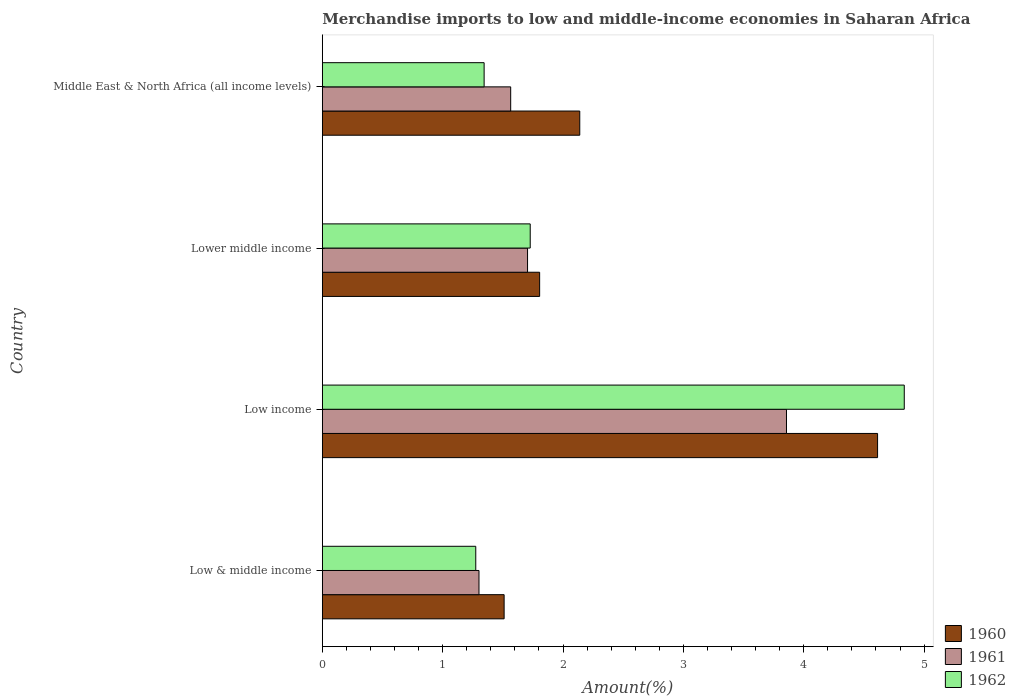How many different coloured bars are there?
Give a very brief answer. 3. Are the number of bars on each tick of the Y-axis equal?
Provide a succinct answer. Yes. How many bars are there on the 1st tick from the bottom?
Ensure brevity in your answer.  3. What is the percentage of amount earned from merchandise imports in 1960 in Low & middle income?
Your response must be concise. 1.51. Across all countries, what is the maximum percentage of amount earned from merchandise imports in 1961?
Provide a succinct answer. 3.86. Across all countries, what is the minimum percentage of amount earned from merchandise imports in 1962?
Offer a very short reply. 1.27. In which country was the percentage of amount earned from merchandise imports in 1962 minimum?
Your answer should be very brief. Low & middle income. What is the total percentage of amount earned from merchandise imports in 1962 in the graph?
Offer a terse response. 9.18. What is the difference between the percentage of amount earned from merchandise imports in 1961 in Low income and that in Middle East & North Africa (all income levels)?
Offer a terse response. 2.29. What is the difference between the percentage of amount earned from merchandise imports in 1961 in Low & middle income and the percentage of amount earned from merchandise imports in 1960 in Middle East & North Africa (all income levels)?
Provide a succinct answer. -0.84. What is the average percentage of amount earned from merchandise imports in 1961 per country?
Keep it short and to the point. 2.11. What is the difference between the percentage of amount earned from merchandise imports in 1962 and percentage of amount earned from merchandise imports in 1961 in Lower middle income?
Make the answer very short. 0.02. What is the ratio of the percentage of amount earned from merchandise imports in 1962 in Low & middle income to that in Lower middle income?
Your answer should be very brief. 0.74. Is the percentage of amount earned from merchandise imports in 1961 in Low & middle income less than that in Lower middle income?
Offer a very short reply. Yes. Is the difference between the percentage of amount earned from merchandise imports in 1962 in Low income and Middle East & North Africa (all income levels) greater than the difference between the percentage of amount earned from merchandise imports in 1961 in Low income and Middle East & North Africa (all income levels)?
Offer a very short reply. Yes. What is the difference between the highest and the second highest percentage of amount earned from merchandise imports in 1961?
Your answer should be compact. 2.15. What is the difference between the highest and the lowest percentage of amount earned from merchandise imports in 1962?
Keep it short and to the point. 3.56. What does the 2nd bar from the top in Lower middle income represents?
Provide a short and direct response. 1961. How many bars are there?
Your response must be concise. 12. Are the values on the major ticks of X-axis written in scientific E-notation?
Provide a short and direct response. No. Where does the legend appear in the graph?
Give a very brief answer. Bottom right. How many legend labels are there?
Give a very brief answer. 3. How are the legend labels stacked?
Keep it short and to the point. Vertical. What is the title of the graph?
Provide a succinct answer. Merchandise imports to low and middle-income economies in Saharan Africa. Does "1988" appear as one of the legend labels in the graph?
Offer a terse response. No. What is the label or title of the X-axis?
Provide a succinct answer. Amount(%). What is the label or title of the Y-axis?
Provide a succinct answer. Country. What is the Amount(%) in 1960 in Low & middle income?
Your answer should be very brief. 1.51. What is the Amount(%) of 1961 in Low & middle income?
Offer a very short reply. 1.3. What is the Amount(%) in 1962 in Low & middle income?
Give a very brief answer. 1.27. What is the Amount(%) of 1960 in Low income?
Keep it short and to the point. 4.61. What is the Amount(%) in 1961 in Low income?
Your answer should be very brief. 3.86. What is the Amount(%) in 1962 in Low income?
Offer a very short reply. 4.84. What is the Amount(%) of 1960 in Lower middle income?
Provide a short and direct response. 1.81. What is the Amount(%) of 1961 in Lower middle income?
Offer a terse response. 1.71. What is the Amount(%) in 1962 in Lower middle income?
Offer a very short reply. 1.73. What is the Amount(%) of 1960 in Middle East & North Africa (all income levels)?
Provide a succinct answer. 2.14. What is the Amount(%) of 1961 in Middle East & North Africa (all income levels)?
Give a very brief answer. 1.57. What is the Amount(%) in 1962 in Middle East & North Africa (all income levels)?
Provide a succinct answer. 1.34. Across all countries, what is the maximum Amount(%) in 1960?
Provide a short and direct response. 4.61. Across all countries, what is the maximum Amount(%) in 1961?
Your response must be concise. 3.86. Across all countries, what is the maximum Amount(%) of 1962?
Give a very brief answer. 4.84. Across all countries, what is the minimum Amount(%) in 1960?
Your answer should be compact. 1.51. Across all countries, what is the minimum Amount(%) of 1961?
Keep it short and to the point. 1.3. Across all countries, what is the minimum Amount(%) in 1962?
Offer a very short reply. 1.27. What is the total Amount(%) in 1960 in the graph?
Provide a short and direct response. 10.07. What is the total Amount(%) in 1961 in the graph?
Ensure brevity in your answer.  8.43. What is the total Amount(%) in 1962 in the graph?
Make the answer very short. 9.18. What is the difference between the Amount(%) of 1960 in Low & middle income and that in Low income?
Give a very brief answer. -3.1. What is the difference between the Amount(%) of 1961 in Low & middle income and that in Low income?
Ensure brevity in your answer.  -2.56. What is the difference between the Amount(%) in 1962 in Low & middle income and that in Low income?
Your answer should be compact. -3.56. What is the difference between the Amount(%) of 1960 in Low & middle income and that in Lower middle income?
Offer a very short reply. -0.29. What is the difference between the Amount(%) of 1961 in Low & middle income and that in Lower middle income?
Your answer should be compact. -0.4. What is the difference between the Amount(%) of 1962 in Low & middle income and that in Lower middle income?
Your response must be concise. -0.45. What is the difference between the Amount(%) in 1960 in Low & middle income and that in Middle East & North Africa (all income levels)?
Your answer should be very brief. -0.63. What is the difference between the Amount(%) of 1961 in Low & middle income and that in Middle East & North Africa (all income levels)?
Offer a terse response. -0.26. What is the difference between the Amount(%) in 1962 in Low & middle income and that in Middle East & North Africa (all income levels)?
Your answer should be compact. -0.07. What is the difference between the Amount(%) of 1960 in Low income and that in Lower middle income?
Make the answer very short. 2.81. What is the difference between the Amount(%) of 1961 in Low income and that in Lower middle income?
Provide a succinct answer. 2.15. What is the difference between the Amount(%) of 1962 in Low income and that in Lower middle income?
Your answer should be compact. 3.11. What is the difference between the Amount(%) of 1960 in Low income and that in Middle East & North Africa (all income levels)?
Make the answer very short. 2.47. What is the difference between the Amount(%) of 1961 in Low income and that in Middle East & North Africa (all income levels)?
Provide a short and direct response. 2.29. What is the difference between the Amount(%) of 1962 in Low income and that in Middle East & North Africa (all income levels)?
Your response must be concise. 3.49. What is the difference between the Amount(%) in 1960 in Lower middle income and that in Middle East & North Africa (all income levels)?
Offer a very short reply. -0.33. What is the difference between the Amount(%) of 1961 in Lower middle income and that in Middle East & North Africa (all income levels)?
Provide a short and direct response. 0.14. What is the difference between the Amount(%) in 1962 in Lower middle income and that in Middle East & North Africa (all income levels)?
Make the answer very short. 0.38. What is the difference between the Amount(%) in 1960 in Low & middle income and the Amount(%) in 1961 in Low income?
Offer a very short reply. -2.35. What is the difference between the Amount(%) of 1960 in Low & middle income and the Amount(%) of 1962 in Low income?
Make the answer very short. -3.32. What is the difference between the Amount(%) in 1961 in Low & middle income and the Amount(%) in 1962 in Low income?
Offer a terse response. -3.53. What is the difference between the Amount(%) in 1960 in Low & middle income and the Amount(%) in 1961 in Lower middle income?
Give a very brief answer. -0.19. What is the difference between the Amount(%) of 1960 in Low & middle income and the Amount(%) of 1962 in Lower middle income?
Give a very brief answer. -0.22. What is the difference between the Amount(%) of 1961 in Low & middle income and the Amount(%) of 1962 in Lower middle income?
Your answer should be compact. -0.43. What is the difference between the Amount(%) in 1960 in Low & middle income and the Amount(%) in 1961 in Middle East & North Africa (all income levels)?
Offer a very short reply. -0.05. What is the difference between the Amount(%) of 1960 in Low & middle income and the Amount(%) of 1962 in Middle East & North Africa (all income levels)?
Your answer should be compact. 0.17. What is the difference between the Amount(%) in 1961 in Low & middle income and the Amount(%) in 1962 in Middle East & North Africa (all income levels)?
Provide a succinct answer. -0.04. What is the difference between the Amount(%) in 1960 in Low income and the Amount(%) in 1961 in Lower middle income?
Provide a short and direct response. 2.91. What is the difference between the Amount(%) in 1960 in Low income and the Amount(%) in 1962 in Lower middle income?
Offer a very short reply. 2.89. What is the difference between the Amount(%) in 1961 in Low income and the Amount(%) in 1962 in Lower middle income?
Ensure brevity in your answer.  2.13. What is the difference between the Amount(%) in 1960 in Low income and the Amount(%) in 1961 in Middle East & North Africa (all income levels)?
Offer a terse response. 3.05. What is the difference between the Amount(%) of 1960 in Low income and the Amount(%) of 1962 in Middle East & North Africa (all income levels)?
Your response must be concise. 3.27. What is the difference between the Amount(%) of 1961 in Low income and the Amount(%) of 1962 in Middle East & North Africa (all income levels)?
Keep it short and to the point. 2.51. What is the difference between the Amount(%) of 1960 in Lower middle income and the Amount(%) of 1961 in Middle East & North Africa (all income levels)?
Provide a succinct answer. 0.24. What is the difference between the Amount(%) in 1960 in Lower middle income and the Amount(%) in 1962 in Middle East & North Africa (all income levels)?
Your response must be concise. 0.46. What is the difference between the Amount(%) in 1961 in Lower middle income and the Amount(%) in 1962 in Middle East & North Africa (all income levels)?
Keep it short and to the point. 0.36. What is the average Amount(%) of 1960 per country?
Your answer should be very brief. 2.52. What is the average Amount(%) in 1961 per country?
Provide a succinct answer. 2.11. What is the average Amount(%) in 1962 per country?
Your response must be concise. 2.3. What is the difference between the Amount(%) of 1960 and Amount(%) of 1961 in Low & middle income?
Make the answer very short. 0.21. What is the difference between the Amount(%) of 1960 and Amount(%) of 1962 in Low & middle income?
Your answer should be compact. 0.24. What is the difference between the Amount(%) in 1961 and Amount(%) in 1962 in Low & middle income?
Your answer should be very brief. 0.03. What is the difference between the Amount(%) of 1960 and Amount(%) of 1961 in Low income?
Provide a succinct answer. 0.76. What is the difference between the Amount(%) in 1960 and Amount(%) in 1962 in Low income?
Give a very brief answer. -0.22. What is the difference between the Amount(%) of 1961 and Amount(%) of 1962 in Low income?
Offer a very short reply. -0.98. What is the difference between the Amount(%) of 1960 and Amount(%) of 1961 in Lower middle income?
Give a very brief answer. 0.1. What is the difference between the Amount(%) of 1960 and Amount(%) of 1962 in Lower middle income?
Your response must be concise. 0.08. What is the difference between the Amount(%) of 1961 and Amount(%) of 1962 in Lower middle income?
Provide a succinct answer. -0.02. What is the difference between the Amount(%) in 1960 and Amount(%) in 1961 in Middle East & North Africa (all income levels)?
Your response must be concise. 0.57. What is the difference between the Amount(%) in 1960 and Amount(%) in 1962 in Middle East & North Africa (all income levels)?
Offer a terse response. 0.79. What is the difference between the Amount(%) of 1961 and Amount(%) of 1962 in Middle East & North Africa (all income levels)?
Make the answer very short. 0.22. What is the ratio of the Amount(%) in 1960 in Low & middle income to that in Low income?
Provide a short and direct response. 0.33. What is the ratio of the Amount(%) of 1961 in Low & middle income to that in Low income?
Your answer should be very brief. 0.34. What is the ratio of the Amount(%) of 1962 in Low & middle income to that in Low income?
Offer a very short reply. 0.26. What is the ratio of the Amount(%) of 1960 in Low & middle income to that in Lower middle income?
Keep it short and to the point. 0.84. What is the ratio of the Amount(%) in 1961 in Low & middle income to that in Lower middle income?
Ensure brevity in your answer.  0.76. What is the ratio of the Amount(%) of 1962 in Low & middle income to that in Lower middle income?
Provide a short and direct response. 0.74. What is the ratio of the Amount(%) of 1960 in Low & middle income to that in Middle East & North Africa (all income levels)?
Offer a terse response. 0.71. What is the ratio of the Amount(%) in 1961 in Low & middle income to that in Middle East & North Africa (all income levels)?
Your response must be concise. 0.83. What is the ratio of the Amount(%) of 1962 in Low & middle income to that in Middle East & North Africa (all income levels)?
Provide a succinct answer. 0.95. What is the ratio of the Amount(%) in 1960 in Low income to that in Lower middle income?
Your response must be concise. 2.56. What is the ratio of the Amount(%) in 1961 in Low income to that in Lower middle income?
Give a very brief answer. 2.26. What is the ratio of the Amount(%) of 1962 in Low income to that in Lower middle income?
Your response must be concise. 2.8. What is the ratio of the Amount(%) of 1960 in Low income to that in Middle East & North Africa (all income levels)?
Give a very brief answer. 2.16. What is the ratio of the Amount(%) in 1961 in Low income to that in Middle East & North Africa (all income levels)?
Offer a terse response. 2.46. What is the ratio of the Amount(%) of 1962 in Low income to that in Middle East & North Africa (all income levels)?
Provide a succinct answer. 3.6. What is the ratio of the Amount(%) of 1960 in Lower middle income to that in Middle East & North Africa (all income levels)?
Ensure brevity in your answer.  0.84. What is the ratio of the Amount(%) in 1961 in Lower middle income to that in Middle East & North Africa (all income levels)?
Ensure brevity in your answer.  1.09. What is the ratio of the Amount(%) in 1962 in Lower middle income to that in Middle East & North Africa (all income levels)?
Your answer should be very brief. 1.28. What is the difference between the highest and the second highest Amount(%) of 1960?
Your answer should be very brief. 2.47. What is the difference between the highest and the second highest Amount(%) in 1961?
Your answer should be very brief. 2.15. What is the difference between the highest and the second highest Amount(%) of 1962?
Give a very brief answer. 3.11. What is the difference between the highest and the lowest Amount(%) of 1960?
Offer a very short reply. 3.1. What is the difference between the highest and the lowest Amount(%) in 1961?
Your answer should be compact. 2.56. What is the difference between the highest and the lowest Amount(%) of 1962?
Keep it short and to the point. 3.56. 